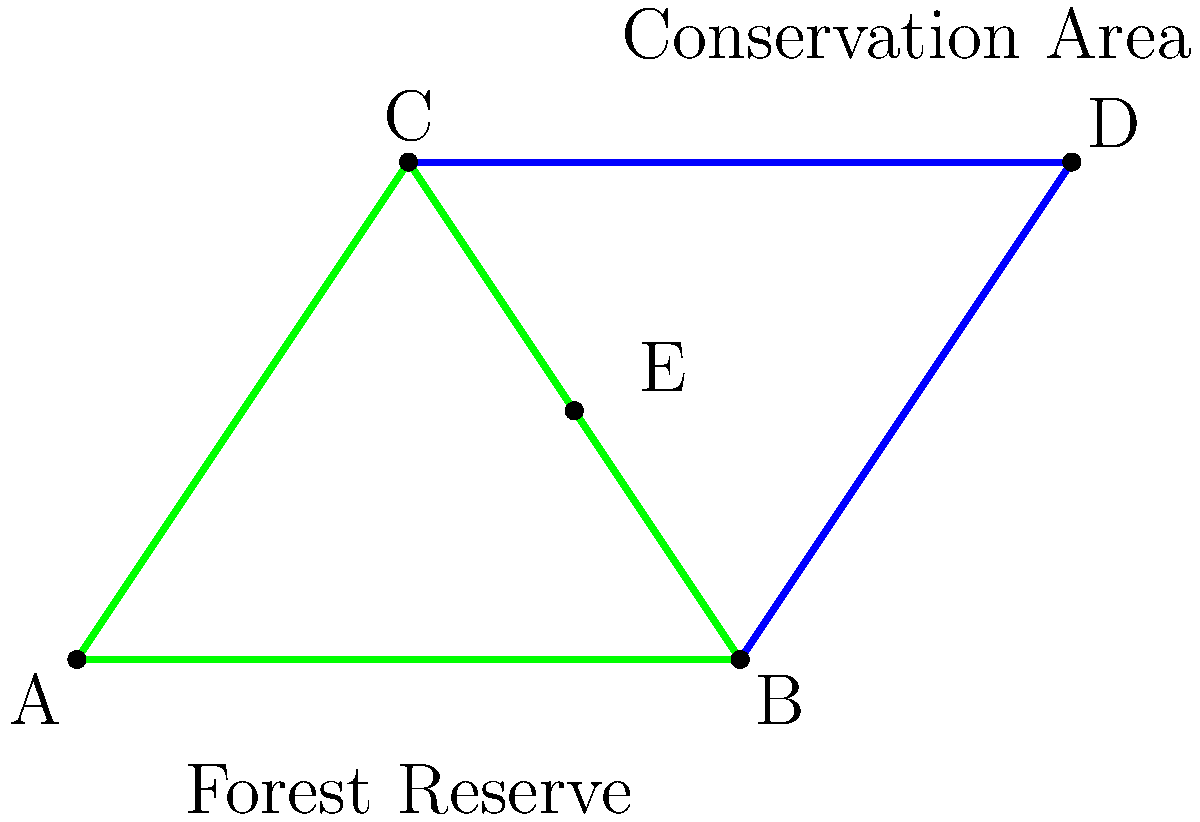In the forest conservation diagram, triangles ABC and BCD represent two adjacent areas of a protected forest. Given that BE is a median of triangle ABC, and CE is a median of triangle BCD, which pair of triangles can be proven congruent using the Side-Angle-Side (SAS) congruence criterion? Let's approach this step-by-step:

1) First, we need to identify the properties of medians:
   - BE is a median of triangle ABC, so it connects vertex B to the midpoint of side AC.
   - CE is a median of triangle BCD, so it connects vertex C to the midpoint of side BD.

2) This means that point E is the midpoint of both AC and BD.

3) Now, let's look at triangles ABE and CBE:
   - AB = CB (given in the question as part of the same triangle ABC)
   - BE is common to both triangles
   - Angle ABE = Angle CBE (vertically opposite angles)

4) These three conditions (Side-Angle-Side) are sufficient to prove that triangles ABE and CBE are congruent.

5) We can make a similar argument for triangles BCE and DCE:
   - BC is common to both triangles
   - CE is common to both triangles
   - Angle BCE = Angle DCE (vertically opposite angles)

6) Again, these three conditions (Side-Angle-Side) prove that triangles BCE and DCE are congruent.

Therefore, we have two pairs of congruent triangles: ABE and CBE, and BCE and DCE. However, the question asks for only one pair, so we can choose either.
Answer: ABE and CBE 